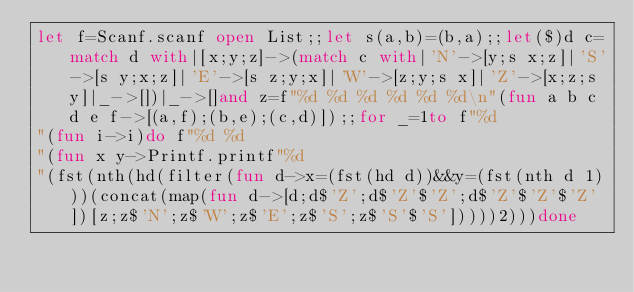<code> <loc_0><loc_0><loc_500><loc_500><_OCaml_>let f=Scanf.scanf open List;;let s(a,b)=(b,a);;let($)d c=match d with|[x;y;z]->(match c with|'N'->[y;s x;z]|'S'->[s y;x;z]|'E'->[s z;y;x]|'W'->[z;y;s x]|'Z'->[x;z;s y]|_->[])|_->[]and z=f"%d %d %d %d %d %d\n"(fun a b c d e f->[(a,f);(b,e);(c,d)]);;for _=1to f"%d
"(fun i->i)do f"%d %d
"(fun x y->Printf.printf"%d
"(fst(nth(hd(filter(fun d->x=(fst(hd d))&&y=(fst(nth d 1)))(concat(map(fun d->[d;d$'Z';d$'Z'$'Z';d$'Z'$'Z'$'Z'])[z;z$'N';z$'W';z$'E';z$'S';z$'S'$'S']))))2)))done</code> 